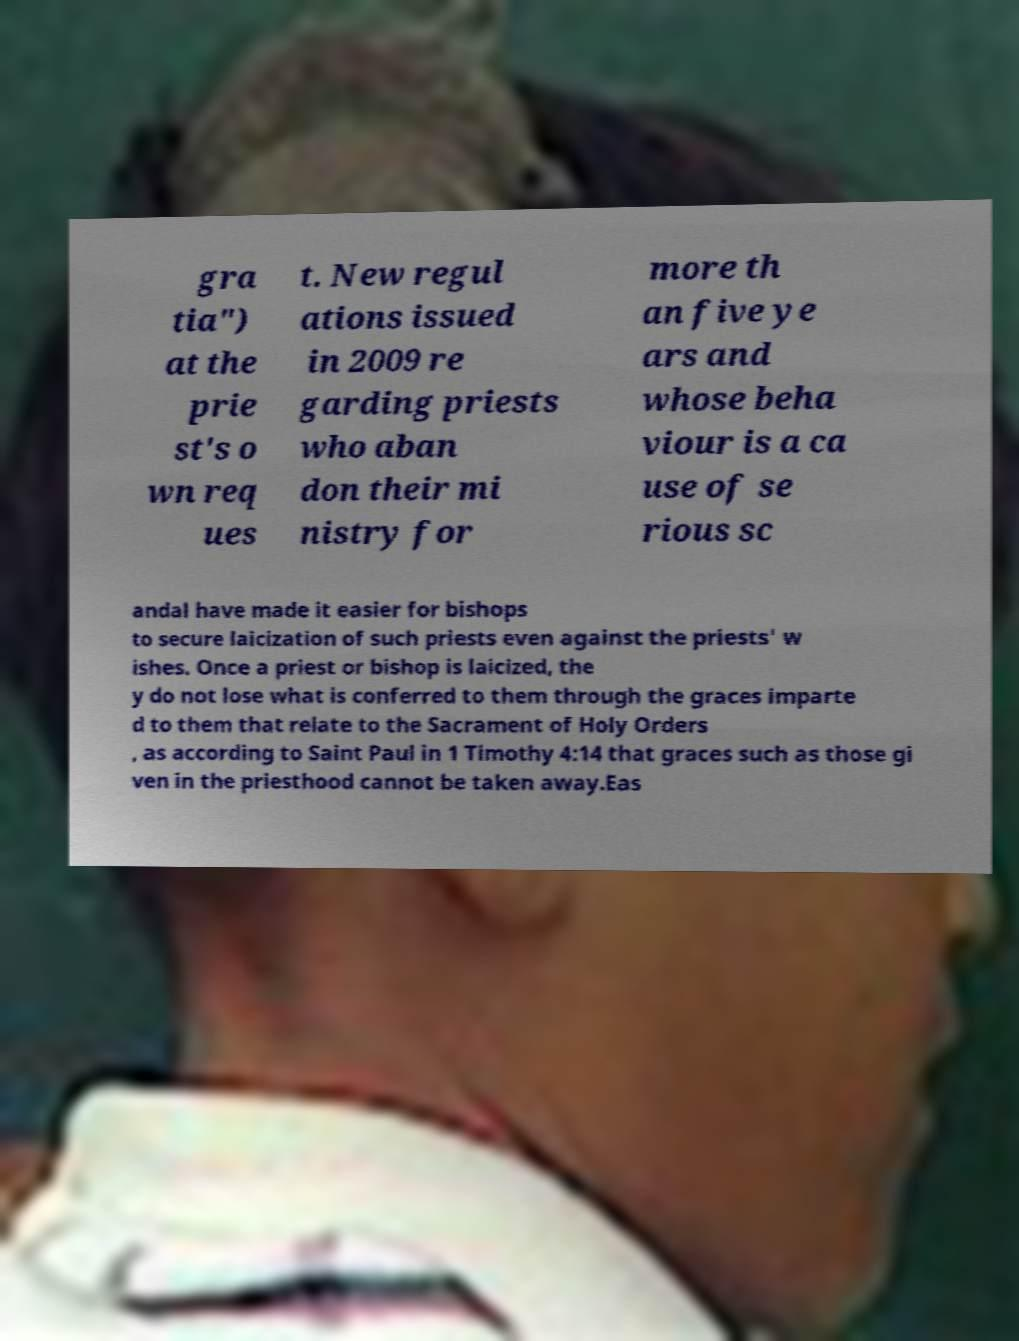I need the written content from this picture converted into text. Can you do that? gra tia") at the prie st's o wn req ues t. New regul ations issued in 2009 re garding priests who aban don their mi nistry for more th an five ye ars and whose beha viour is a ca use of se rious sc andal have made it easier for bishops to secure laicization of such priests even against the priests' w ishes. Once a priest or bishop is laicized, the y do not lose what is conferred to them through the graces imparte d to them that relate to the Sacrament of Holy Orders , as according to Saint Paul in 1 Timothy 4:14 that graces such as those gi ven in the priesthood cannot be taken away.Eas 